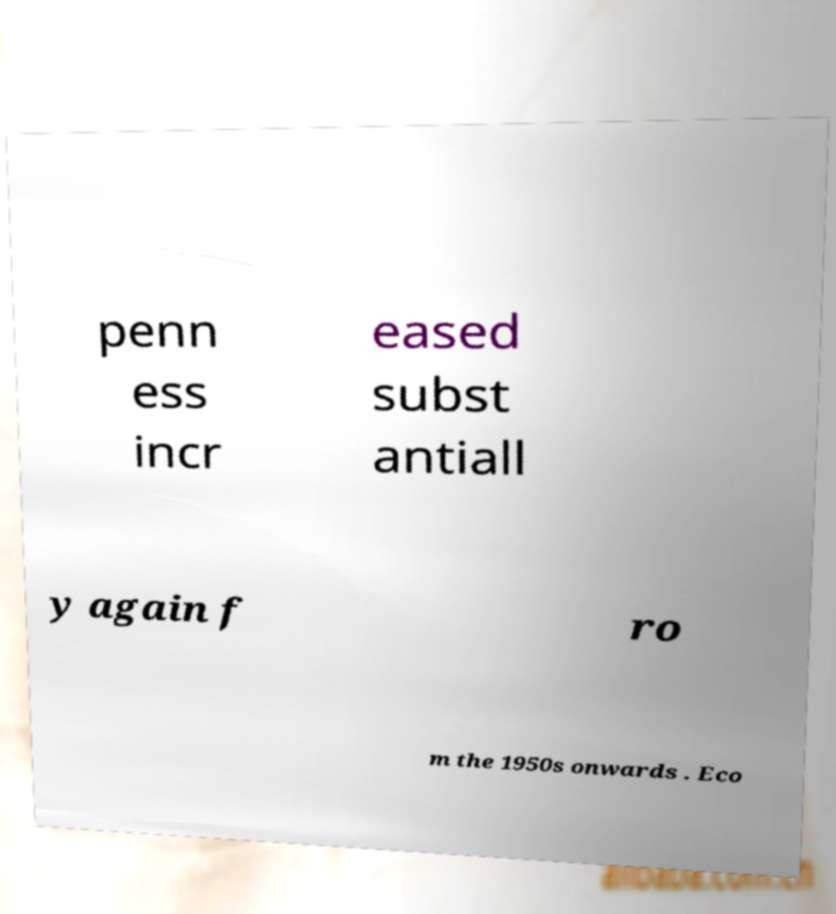There's text embedded in this image that I need extracted. Can you transcribe it verbatim? penn ess incr eased subst antiall y again f ro m the 1950s onwards . Eco 